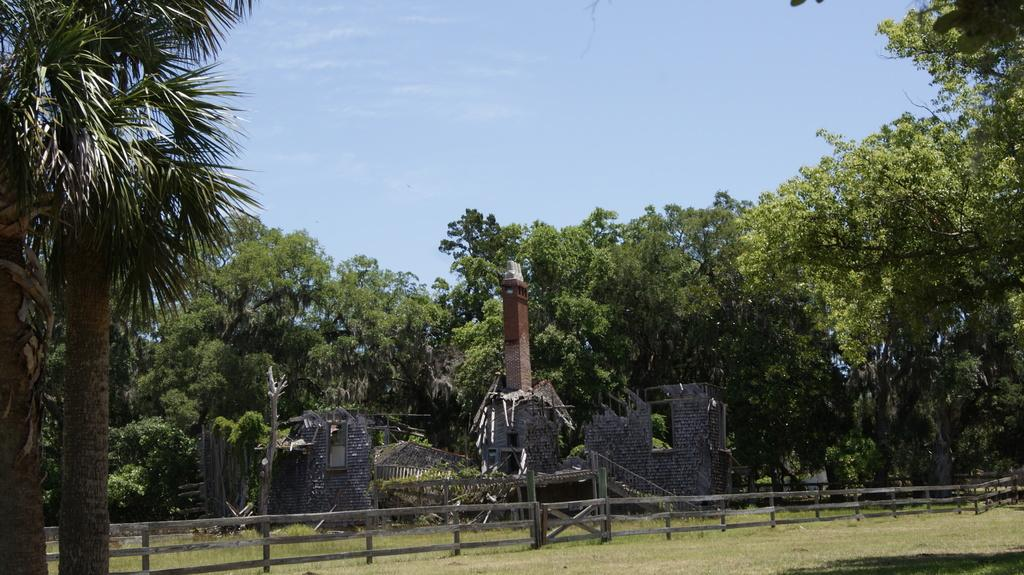What type of fence is present in the image? There is a wooden fence in the image. What structure can be seen behind the wooden fence? There is a ruined house behind the wooden fence. What can be seen beyond the ruined house? There are trees visible behind the ruined house. How many notebooks are stacked on the wooden fence in the image? There are no notebooks present in the image. What is the mass of the trees visible behind the ruined house? The mass of the trees cannot be determined from the image. 